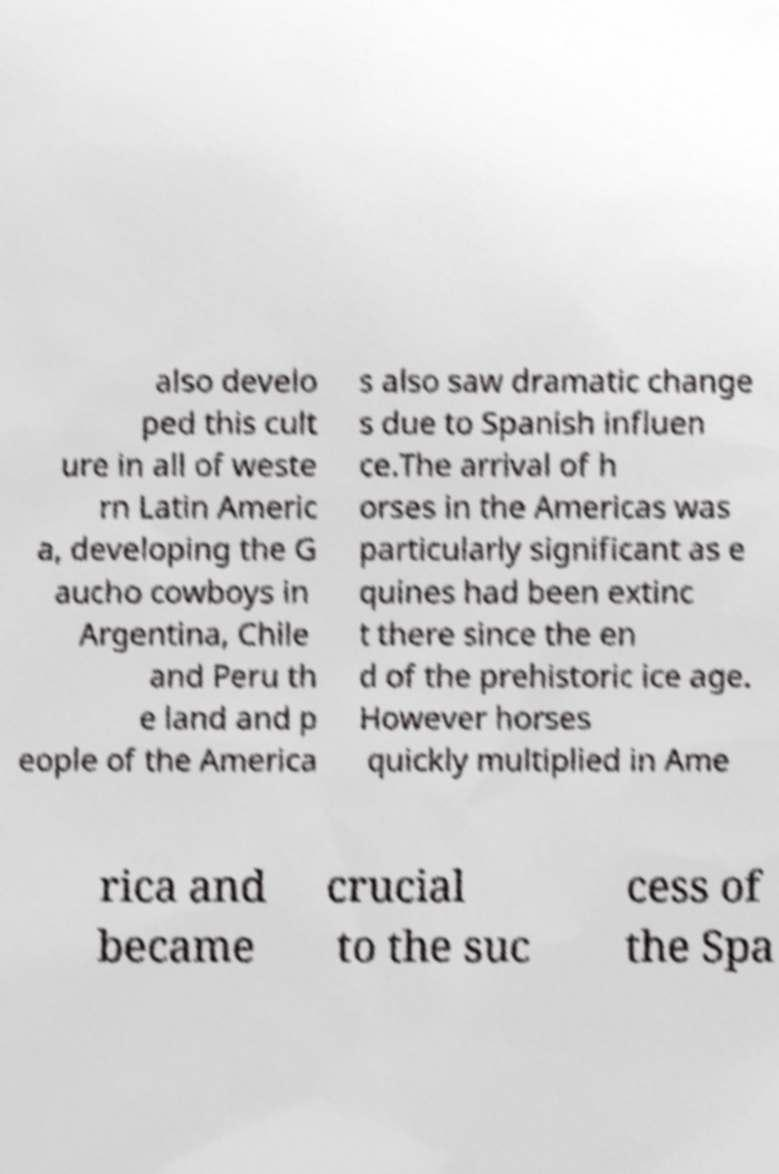Could you assist in decoding the text presented in this image and type it out clearly? also develo ped this cult ure in all of weste rn Latin Americ a, developing the G aucho cowboys in Argentina, Chile and Peru th e land and p eople of the America s also saw dramatic change s due to Spanish influen ce.The arrival of h orses in the Americas was particularly significant as e quines had been extinc t there since the en d of the prehistoric ice age. However horses quickly multiplied in Ame rica and became crucial to the suc cess of the Spa 